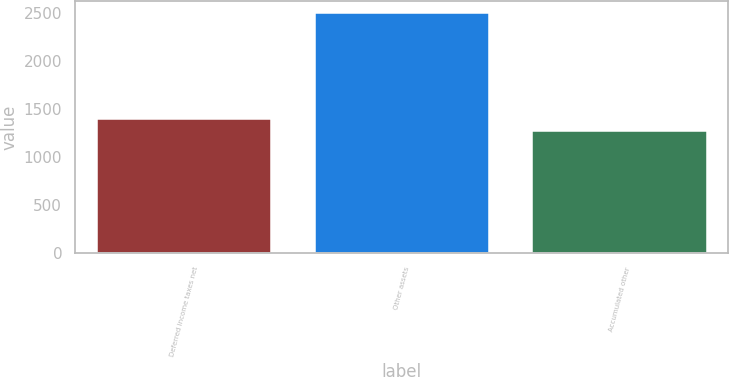Convert chart to OTSL. <chart><loc_0><loc_0><loc_500><loc_500><bar_chart><fcel>Deferred income taxes net<fcel>Other assets<fcel>Accumulated other<nl><fcel>1392.4<fcel>2494<fcel>1270<nl></chart> 